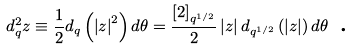Convert formula to latex. <formula><loc_0><loc_0><loc_500><loc_500>d _ { q } ^ { 2 } z \equiv \frac { 1 } { 2 } d _ { q } \left ( \left | z \right | ^ { 2 } \right ) d \theta = \frac { \left [ 2 \right ] _ { q ^ { 1 / 2 } } } { 2 } \left | z \right | d _ { q ^ { 1 / 2 } } \left ( \left | z \right | \right ) d \theta \text { .}</formula> 